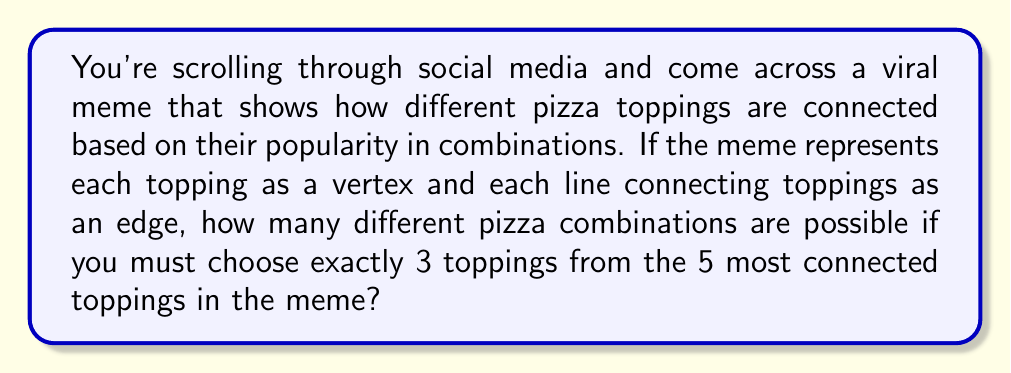Could you help me with this problem? Let's break this down step-by-step:

1) First, we need to understand what the question is asking. We're looking at a meme that represents pizza toppings as a graph, where toppings are vertices and their combinations are edges.

2) We're told to focus on the 5 most connected toppings. In graph theory, the number of connections a vertex has is called its degree.

3) We need to choose 3 toppings out of these 5. This is a combination problem.

4) The formula for combinations is:

   $$C(n,r) = \frac{n!}{r!(n-r)!}$$

   Where $n$ is the total number of items to choose from, and $r$ is the number of items being chosen.

5) In this case, $n = 5$ (total toppings) and $r = 3$ (toppings we're choosing).

6) Let's plug these numbers into our formula:

   $$C(5,3) = \frac{5!}{3!(5-3)!} = \frac{5!}{3!2!}$$

7) Expand this:
   $$\frac{5 * 4 * 3!}{3! * 2 * 1}$$

8) The 3! cancels out:
   $$\frac{5 * 4}{2 * 1} = \frac{20}{2} = 10$$

Therefore, there are 10 possible combinations of 3 toppings chosen from the 5 most connected toppings in the meme.
Answer: 10 combinations 